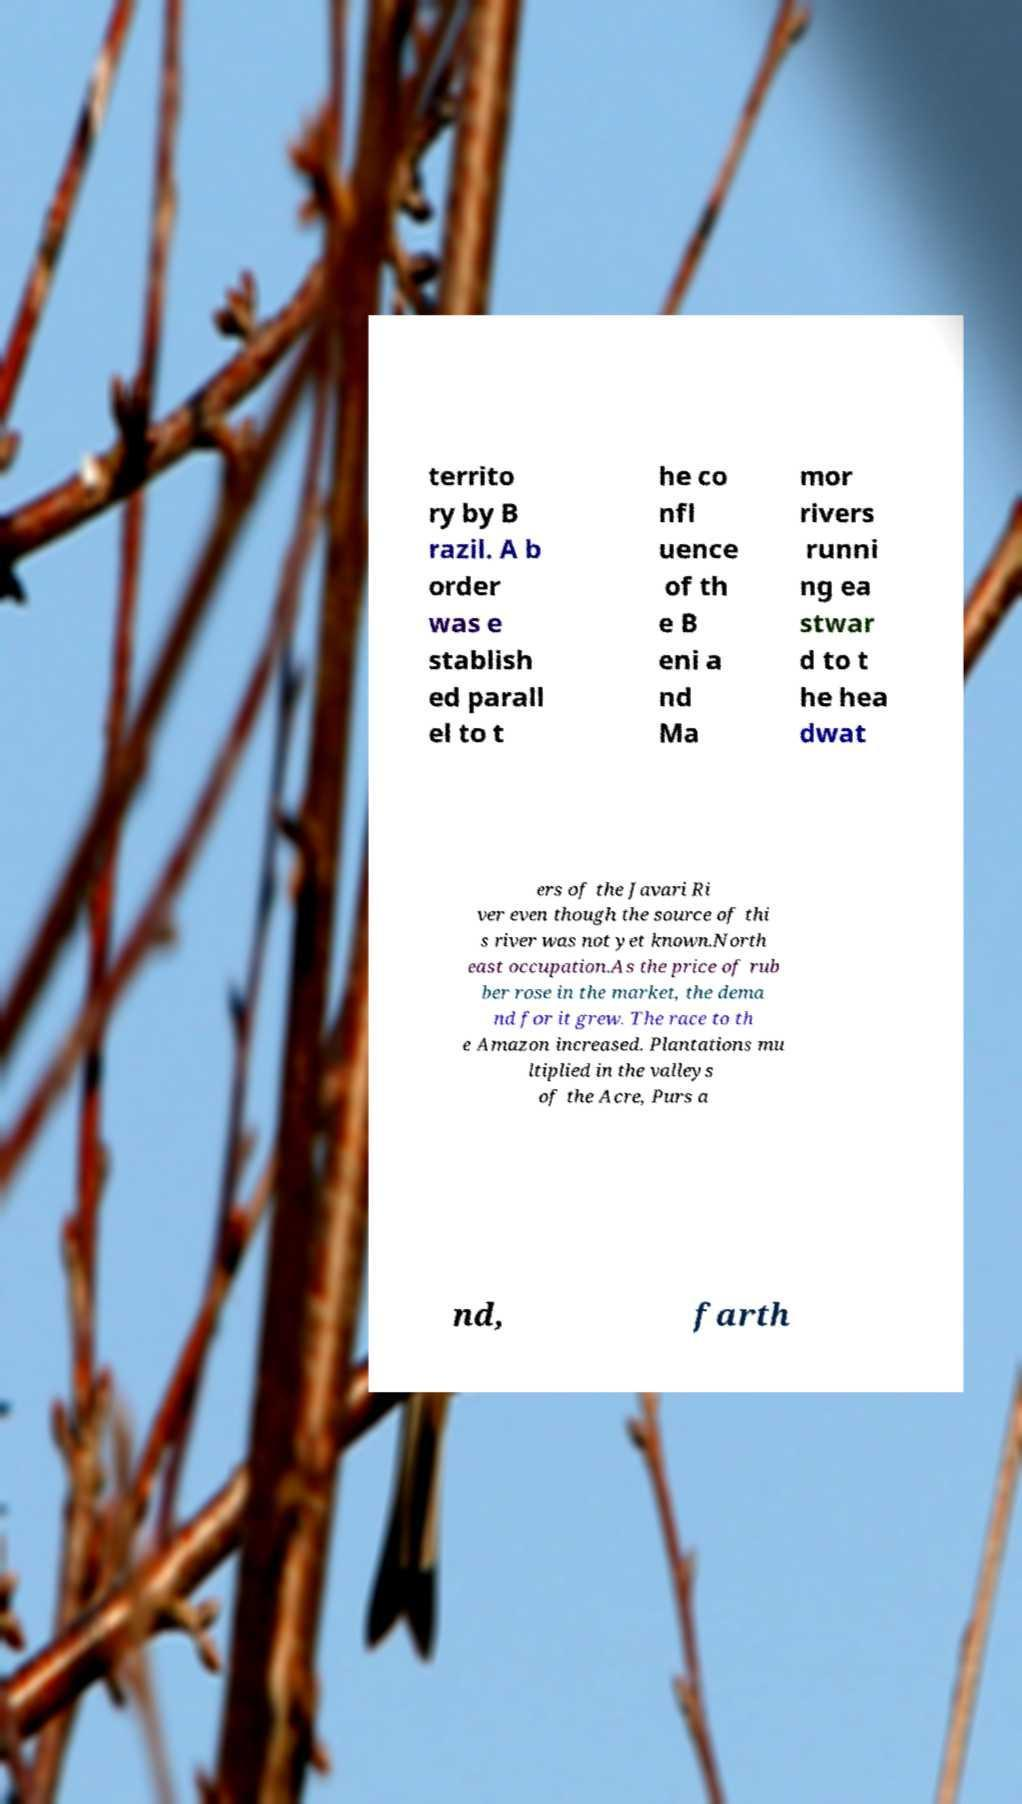There's text embedded in this image that I need extracted. Can you transcribe it verbatim? territo ry by B razil. A b order was e stablish ed parall el to t he co nfl uence of th e B eni a nd Ma mor rivers runni ng ea stwar d to t he hea dwat ers of the Javari Ri ver even though the source of thi s river was not yet known.North east occupation.As the price of rub ber rose in the market, the dema nd for it grew. The race to th e Amazon increased. Plantations mu ltiplied in the valleys of the Acre, Purs a nd, farth 